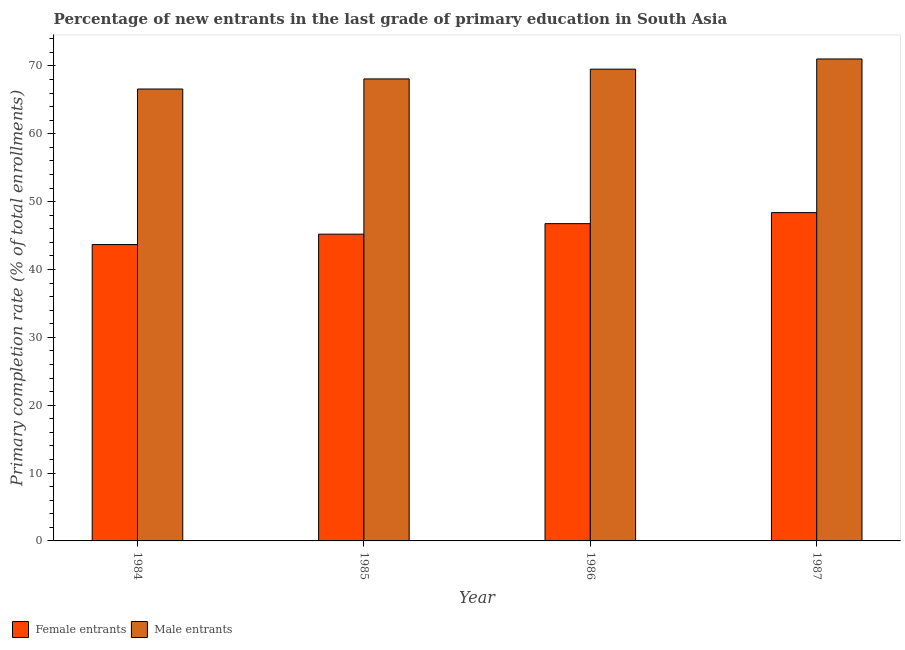Are the number of bars on each tick of the X-axis equal?
Your answer should be very brief. Yes. How many bars are there on the 3rd tick from the left?
Your answer should be compact. 2. How many bars are there on the 4th tick from the right?
Provide a succinct answer. 2. What is the label of the 3rd group of bars from the left?
Provide a succinct answer. 1986. What is the primary completion rate of female entrants in 1987?
Offer a very short reply. 48.39. Across all years, what is the maximum primary completion rate of female entrants?
Make the answer very short. 48.39. Across all years, what is the minimum primary completion rate of female entrants?
Ensure brevity in your answer.  43.68. In which year was the primary completion rate of male entrants minimum?
Your response must be concise. 1984. What is the total primary completion rate of female entrants in the graph?
Provide a short and direct response. 184.03. What is the difference between the primary completion rate of male entrants in 1984 and that in 1985?
Ensure brevity in your answer.  -1.49. What is the difference between the primary completion rate of female entrants in 1984 and the primary completion rate of male entrants in 1985?
Offer a very short reply. -1.53. What is the average primary completion rate of female entrants per year?
Ensure brevity in your answer.  46.01. In the year 1986, what is the difference between the primary completion rate of male entrants and primary completion rate of female entrants?
Your answer should be very brief. 0. What is the ratio of the primary completion rate of female entrants in 1985 to that in 1986?
Provide a short and direct response. 0.97. What is the difference between the highest and the second highest primary completion rate of female entrants?
Your response must be concise. 1.63. What is the difference between the highest and the lowest primary completion rate of male entrants?
Keep it short and to the point. 4.43. In how many years, is the primary completion rate of male entrants greater than the average primary completion rate of male entrants taken over all years?
Provide a succinct answer. 2. What does the 1st bar from the left in 1987 represents?
Ensure brevity in your answer.  Female entrants. What does the 2nd bar from the right in 1986 represents?
Your answer should be compact. Female entrants. Are all the bars in the graph horizontal?
Your answer should be very brief. No. Does the graph contain any zero values?
Your answer should be compact. No. What is the title of the graph?
Keep it short and to the point. Percentage of new entrants in the last grade of primary education in South Asia. What is the label or title of the Y-axis?
Provide a short and direct response. Primary completion rate (% of total enrollments). What is the Primary completion rate (% of total enrollments) of Female entrants in 1984?
Give a very brief answer. 43.68. What is the Primary completion rate (% of total enrollments) of Male entrants in 1984?
Your answer should be compact. 66.6. What is the Primary completion rate (% of total enrollments) of Female entrants in 1985?
Offer a terse response. 45.21. What is the Primary completion rate (% of total enrollments) of Male entrants in 1985?
Offer a very short reply. 68.09. What is the Primary completion rate (% of total enrollments) in Female entrants in 1986?
Offer a very short reply. 46.76. What is the Primary completion rate (% of total enrollments) of Male entrants in 1986?
Ensure brevity in your answer.  69.53. What is the Primary completion rate (% of total enrollments) in Female entrants in 1987?
Your answer should be very brief. 48.39. What is the Primary completion rate (% of total enrollments) in Male entrants in 1987?
Your answer should be compact. 71.03. Across all years, what is the maximum Primary completion rate (% of total enrollments) in Female entrants?
Your answer should be compact. 48.39. Across all years, what is the maximum Primary completion rate (% of total enrollments) of Male entrants?
Keep it short and to the point. 71.03. Across all years, what is the minimum Primary completion rate (% of total enrollments) in Female entrants?
Give a very brief answer. 43.68. Across all years, what is the minimum Primary completion rate (% of total enrollments) in Male entrants?
Provide a short and direct response. 66.6. What is the total Primary completion rate (% of total enrollments) of Female entrants in the graph?
Give a very brief answer. 184.03. What is the total Primary completion rate (% of total enrollments) in Male entrants in the graph?
Your answer should be very brief. 275.24. What is the difference between the Primary completion rate (% of total enrollments) in Female entrants in 1984 and that in 1985?
Ensure brevity in your answer.  -1.53. What is the difference between the Primary completion rate (% of total enrollments) of Male entrants in 1984 and that in 1985?
Offer a very short reply. -1.49. What is the difference between the Primary completion rate (% of total enrollments) of Female entrants in 1984 and that in 1986?
Your answer should be compact. -3.08. What is the difference between the Primary completion rate (% of total enrollments) in Male entrants in 1984 and that in 1986?
Provide a succinct answer. -2.93. What is the difference between the Primary completion rate (% of total enrollments) of Female entrants in 1984 and that in 1987?
Provide a short and direct response. -4.71. What is the difference between the Primary completion rate (% of total enrollments) of Male entrants in 1984 and that in 1987?
Ensure brevity in your answer.  -4.43. What is the difference between the Primary completion rate (% of total enrollments) in Female entrants in 1985 and that in 1986?
Your answer should be very brief. -1.55. What is the difference between the Primary completion rate (% of total enrollments) of Male entrants in 1985 and that in 1986?
Offer a very short reply. -1.44. What is the difference between the Primary completion rate (% of total enrollments) of Female entrants in 1985 and that in 1987?
Offer a very short reply. -3.18. What is the difference between the Primary completion rate (% of total enrollments) of Male entrants in 1985 and that in 1987?
Your answer should be very brief. -2.94. What is the difference between the Primary completion rate (% of total enrollments) in Female entrants in 1986 and that in 1987?
Provide a short and direct response. -1.63. What is the difference between the Primary completion rate (% of total enrollments) in Male entrants in 1986 and that in 1987?
Offer a terse response. -1.5. What is the difference between the Primary completion rate (% of total enrollments) in Female entrants in 1984 and the Primary completion rate (% of total enrollments) in Male entrants in 1985?
Offer a terse response. -24.41. What is the difference between the Primary completion rate (% of total enrollments) of Female entrants in 1984 and the Primary completion rate (% of total enrollments) of Male entrants in 1986?
Make the answer very short. -25.85. What is the difference between the Primary completion rate (% of total enrollments) in Female entrants in 1984 and the Primary completion rate (% of total enrollments) in Male entrants in 1987?
Offer a very short reply. -27.35. What is the difference between the Primary completion rate (% of total enrollments) in Female entrants in 1985 and the Primary completion rate (% of total enrollments) in Male entrants in 1986?
Provide a short and direct response. -24.32. What is the difference between the Primary completion rate (% of total enrollments) in Female entrants in 1985 and the Primary completion rate (% of total enrollments) in Male entrants in 1987?
Give a very brief answer. -25.82. What is the difference between the Primary completion rate (% of total enrollments) in Female entrants in 1986 and the Primary completion rate (% of total enrollments) in Male entrants in 1987?
Provide a short and direct response. -24.27. What is the average Primary completion rate (% of total enrollments) of Female entrants per year?
Ensure brevity in your answer.  46.01. What is the average Primary completion rate (% of total enrollments) in Male entrants per year?
Ensure brevity in your answer.  68.81. In the year 1984, what is the difference between the Primary completion rate (% of total enrollments) of Female entrants and Primary completion rate (% of total enrollments) of Male entrants?
Provide a succinct answer. -22.92. In the year 1985, what is the difference between the Primary completion rate (% of total enrollments) in Female entrants and Primary completion rate (% of total enrollments) in Male entrants?
Your response must be concise. -22.88. In the year 1986, what is the difference between the Primary completion rate (% of total enrollments) in Female entrants and Primary completion rate (% of total enrollments) in Male entrants?
Provide a succinct answer. -22.77. In the year 1987, what is the difference between the Primary completion rate (% of total enrollments) in Female entrants and Primary completion rate (% of total enrollments) in Male entrants?
Ensure brevity in your answer.  -22.64. What is the ratio of the Primary completion rate (% of total enrollments) of Female entrants in 1984 to that in 1985?
Offer a terse response. 0.97. What is the ratio of the Primary completion rate (% of total enrollments) in Male entrants in 1984 to that in 1985?
Provide a succinct answer. 0.98. What is the ratio of the Primary completion rate (% of total enrollments) in Female entrants in 1984 to that in 1986?
Offer a terse response. 0.93. What is the ratio of the Primary completion rate (% of total enrollments) of Male entrants in 1984 to that in 1986?
Give a very brief answer. 0.96. What is the ratio of the Primary completion rate (% of total enrollments) in Female entrants in 1984 to that in 1987?
Offer a terse response. 0.9. What is the ratio of the Primary completion rate (% of total enrollments) in Male entrants in 1984 to that in 1987?
Offer a very short reply. 0.94. What is the ratio of the Primary completion rate (% of total enrollments) in Female entrants in 1985 to that in 1986?
Make the answer very short. 0.97. What is the ratio of the Primary completion rate (% of total enrollments) of Male entrants in 1985 to that in 1986?
Make the answer very short. 0.98. What is the ratio of the Primary completion rate (% of total enrollments) of Female entrants in 1985 to that in 1987?
Your answer should be compact. 0.93. What is the ratio of the Primary completion rate (% of total enrollments) in Male entrants in 1985 to that in 1987?
Make the answer very short. 0.96. What is the ratio of the Primary completion rate (% of total enrollments) in Female entrants in 1986 to that in 1987?
Ensure brevity in your answer.  0.97. What is the ratio of the Primary completion rate (% of total enrollments) in Male entrants in 1986 to that in 1987?
Your answer should be compact. 0.98. What is the difference between the highest and the second highest Primary completion rate (% of total enrollments) in Female entrants?
Ensure brevity in your answer.  1.63. What is the difference between the highest and the second highest Primary completion rate (% of total enrollments) of Male entrants?
Make the answer very short. 1.5. What is the difference between the highest and the lowest Primary completion rate (% of total enrollments) in Female entrants?
Your response must be concise. 4.71. What is the difference between the highest and the lowest Primary completion rate (% of total enrollments) of Male entrants?
Make the answer very short. 4.43. 